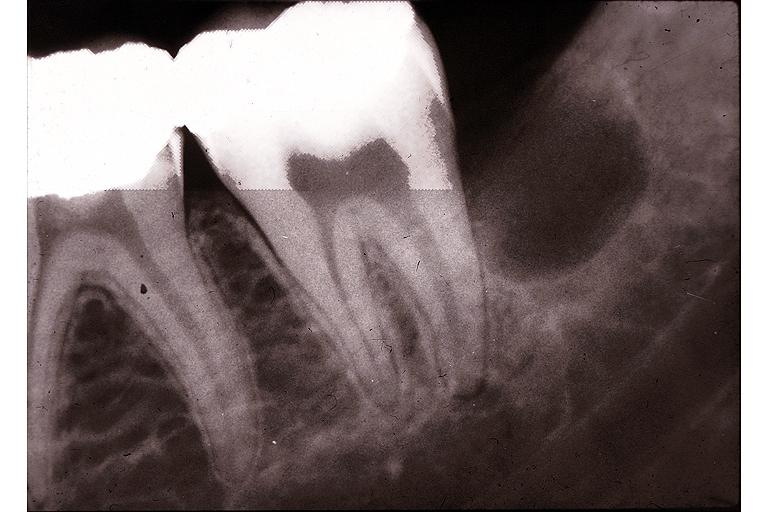does this image show primodial cyst?
Answer the question using a single word or phrase. Yes 